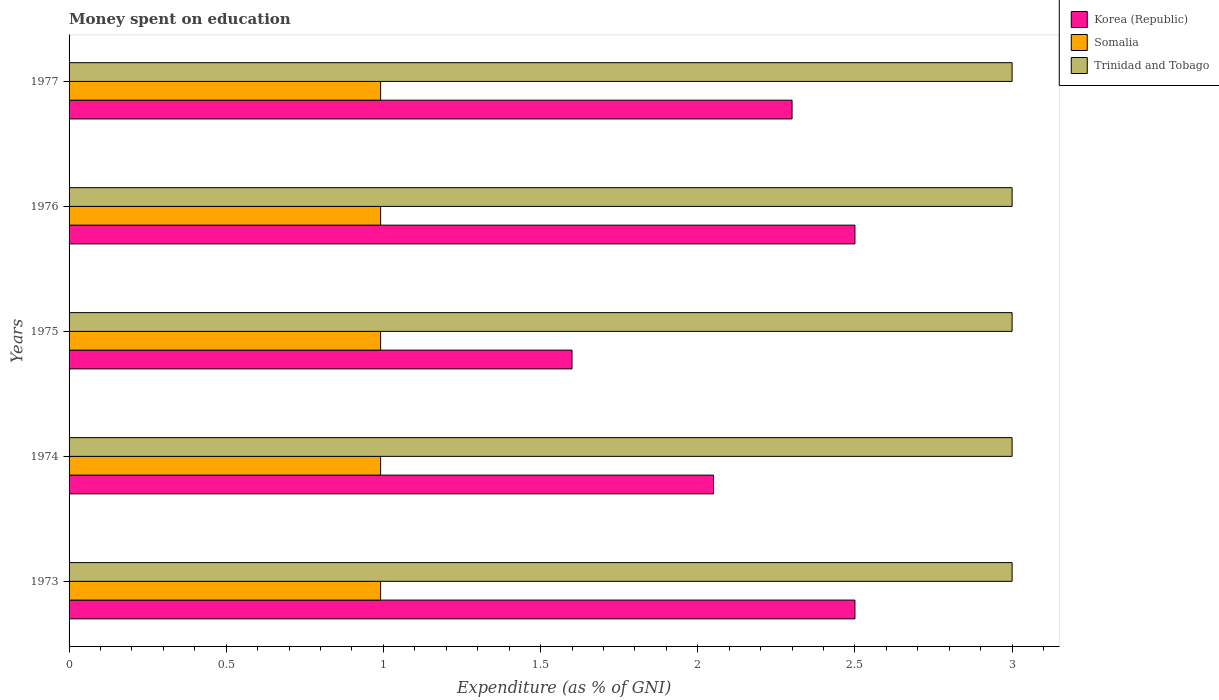How many different coloured bars are there?
Give a very brief answer. 3. Are the number of bars per tick equal to the number of legend labels?
Your answer should be very brief. Yes. Are the number of bars on each tick of the Y-axis equal?
Make the answer very short. Yes. How many bars are there on the 1st tick from the top?
Keep it short and to the point. 3. What is the label of the 1st group of bars from the top?
Your response must be concise. 1977. In how many cases, is the number of bars for a given year not equal to the number of legend labels?
Make the answer very short. 0. What is the amount of money spent on education in Somalia in 1977?
Your answer should be very brief. 0.99. Across all years, what is the minimum amount of money spent on education in Korea (Republic)?
Offer a very short reply. 1.6. In which year was the amount of money spent on education in Korea (Republic) minimum?
Your answer should be compact. 1975. What is the total amount of money spent on education in Korea (Republic) in the graph?
Make the answer very short. 10.95. What is the difference between the amount of money spent on education in Somalia in 1977 and the amount of money spent on education in Trinidad and Tobago in 1975?
Give a very brief answer. -2.01. In the year 1977, what is the difference between the amount of money spent on education in Somalia and amount of money spent on education in Trinidad and Tobago?
Give a very brief answer. -2.01. Is the amount of money spent on education in Korea (Republic) in 1974 less than that in 1976?
Your answer should be compact. Yes. What is the difference between the highest and the second highest amount of money spent on education in Korea (Republic)?
Your answer should be very brief. 0. What is the difference between the highest and the lowest amount of money spent on education in Somalia?
Make the answer very short. 0. In how many years, is the amount of money spent on education in Somalia greater than the average amount of money spent on education in Somalia taken over all years?
Ensure brevity in your answer.  5. What does the 3rd bar from the bottom in 1974 represents?
Offer a terse response. Trinidad and Tobago. How many bars are there?
Your response must be concise. 15. How many years are there in the graph?
Give a very brief answer. 5. What is the difference between two consecutive major ticks on the X-axis?
Your answer should be compact. 0.5. Are the values on the major ticks of X-axis written in scientific E-notation?
Your answer should be very brief. No. Does the graph contain any zero values?
Ensure brevity in your answer.  No. How many legend labels are there?
Offer a terse response. 3. What is the title of the graph?
Your response must be concise. Money spent on education. Does "Zambia" appear as one of the legend labels in the graph?
Offer a terse response. No. What is the label or title of the X-axis?
Ensure brevity in your answer.  Expenditure (as % of GNI). What is the Expenditure (as % of GNI) of Korea (Republic) in 1973?
Your response must be concise. 2.5. What is the Expenditure (as % of GNI) in Somalia in 1973?
Your response must be concise. 0.99. What is the Expenditure (as % of GNI) of Korea (Republic) in 1974?
Ensure brevity in your answer.  2.05. What is the Expenditure (as % of GNI) in Somalia in 1974?
Provide a succinct answer. 0.99. What is the Expenditure (as % of GNI) in Somalia in 1975?
Provide a short and direct response. 0.99. What is the Expenditure (as % of GNI) of Trinidad and Tobago in 1975?
Provide a short and direct response. 3. What is the Expenditure (as % of GNI) of Korea (Republic) in 1976?
Offer a very short reply. 2.5. What is the Expenditure (as % of GNI) in Somalia in 1976?
Give a very brief answer. 0.99. What is the Expenditure (as % of GNI) in Trinidad and Tobago in 1976?
Provide a succinct answer. 3. What is the Expenditure (as % of GNI) in Somalia in 1977?
Provide a succinct answer. 0.99. Across all years, what is the maximum Expenditure (as % of GNI) in Somalia?
Keep it short and to the point. 0.99. Across all years, what is the minimum Expenditure (as % of GNI) in Somalia?
Provide a short and direct response. 0.99. What is the total Expenditure (as % of GNI) of Korea (Republic) in the graph?
Offer a very short reply. 10.95. What is the total Expenditure (as % of GNI) in Somalia in the graph?
Offer a terse response. 4.96. What is the difference between the Expenditure (as % of GNI) of Korea (Republic) in 1973 and that in 1974?
Your answer should be compact. 0.45. What is the difference between the Expenditure (as % of GNI) of Trinidad and Tobago in 1973 and that in 1974?
Offer a very short reply. 0. What is the difference between the Expenditure (as % of GNI) in Korea (Republic) in 1973 and that in 1977?
Give a very brief answer. 0.2. What is the difference between the Expenditure (as % of GNI) in Korea (Republic) in 1974 and that in 1975?
Offer a terse response. 0.45. What is the difference between the Expenditure (as % of GNI) in Somalia in 1974 and that in 1975?
Provide a short and direct response. 0. What is the difference between the Expenditure (as % of GNI) in Korea (Republic) in 1974 and that in 1976?
Your response must be concise. -0.45. What is the difference between the Expenditure (as % of GNI) of Trinidad and Tobago in 1974 and that in 1976?
Give a very brief answer. 0. What is the difference between the Expenditure (as % of GNI) of Korea (Republic) in 1974 and that in 1977?
Your response must be concise. -0.25. What is the difference between the Expenditure (as % of GNI) of Somalia in 1974 and that in 1977?
Offer a very short reply. 0. What is the difference between the Expenditure (as % of GNI) of Somalia in 1975 and that in 1976?
Provide a short and direct response. 0. What is the difference between the Expenditure (as % of GNI) of Trinidad and Tobago in 1975 and that in 1976?
Keep it short and to the point. 0. What is the difference between the Expenditure (as % of GNI) in Korea (Republic) in 1975 and that in 1977?
Make the answer very short. -0.7. What is the difference between the Expenditure (as % of GNI) in Somalia in 1975 and that in 1977?
Offer a terse response. 0. What is the difference between the Expenditure (as % of GNI) of Somalia in 1976 and that in 1977?
Ensure brevity in your answer.  0. What is the difference between the Expenditure (as % of GNI) in Korea (Republic) in 1973 and the Expenditure (as % of GNI) in Somalia in 1974?
Make the answer very short. 1.51. What is the difference between the Expenditure (as % of GNI) in Korea (Republic) in 1973 and the Expenditure (as % of GNI) in Trinidad and Tobago in 1974?
Provide a succinct answer. -0.5. What is the difference between the Expenditure (as % of GNI) of Somalia in 1973 and the Expenditure (as % of GNI) of Trinidad and Tobago in 1974?
Your answer should be compact. -2.01. What is the difference between the Expenditure (as % of GNI) of Korea (Republic) in 1973 and the Expenditure (as % of GNI) of Somalia in 1975?
Make the answer very short. 1.51. What is the difference between the Expenditure (as % of GNI) of Korea (Republic) in 1973 and the Expenditure (as % of GNI) of Trinidad and Tobago in 1975?
Ensure brevity in your answer.  -0.5. What is the difference between the Expenditure (as % of GNI) of Somalia in 1973 and the Expenditure (as % of GNI) of Trinidad and Tobago in 1975?
Provide a short and direct response. -2.01. What is the difference between the Expenditure (as % of GNI) of Korea (Republic) in 1973 and the Expenditure (as % of GNI) of Somalia in 1976?
Provide a succinct answer. 1.51. What is the difference between the Expenditure (as % of GNI) in Korea (Republic) in 1973 and the Expenditure (as % of GNI) in Trinidad and Tobago in 1976?
Provide a short and direct response. -0.5. What is the difference between the Expenditure (as % of GNI) in Somalia in 1973 and the Expenditure (as % of GNI) in Trinidad and Tobago in 1976?
Your answer should be very brief. -2.01. What is the difference between the Expenditure (as % of GNI) in Korea (Republic) in 1973 and the Expenditure (as % of GNI) in Somalia in 1977?
Keep it short and to the point. 1.51. What is the difference between the Expenditure (as % of GNI) of Korea (Republic) in 1973 and the Expenditure (as % of GNI) of Trinidad and Tobago in 1977?
Your answer should be very brief. -0.5. What is the difference between the Expenditure (as % of GNI) of Somalia in 1973 and the Expenditure (as % of GNI) of Trinidad and Tobago in 1977?
Your response must be concise. -2.01. What is the difference between the Expenditure (as % of GNI) of Korea (Republic) in 1974 and the Expenditure (as % of GNI) of Somalia in 1975?
Your answer should be very brief. 1.06. What is the difference between the Expenditure (as % of GNI) in Korea (Republic) in 1974 and the Expenditure (as % of GNI) in Trinidad and Tobago in 1975?
Ensure brevity in your answer.  -0.95. What is the difference between the Expenditure (as % of GNI) in Somalia in 1974 and the Expenditure (as % of GNI) in Trinidad and Tobago in 1975?
Keep it short and to the point. -2.01. What is the difference between the Expenditure (as % of GNI) in Korea (Republic) in 1974 and the Expenditure (as % of GNI) in Somalia in 1976?
Make the answer very short. 1.06. What is the difference between the Expenditure (as % of GNI) of Korea (Republic) in 1974 and the Expenditure (as % of GNI) of Trinidad and Tobago in 1976?
Provide a short and direct response. -0.95. What is the difference between the Expenditure (as % of GNI) in Somalia in 1974 and the Expenditure (as % of GNI) in Trinidad and Tobago in 1976?
Make the answer very short. -2.01. What is the difference between the Expenditure (as % of GNI) of Korea (Republic) in 1974 and the Expenditure (as % of GNI) of Somalia in 1977?
Provide a short and direct response. 1.06. What is the difference between the Expenditure (as % of GNI) in Korea (Republic) in 1974 and the Expenditure (as % of GNI) in Trinidad and Tobago in 1977?
Provide a short and direct response. -0.95. What is the difference between the Expenditure (as % of GNI) of Somalia in 1974 and the Expenditure (as % of GNI) of Trinidad and Tobago in 1977?
Keep it short and to the point. -2.01. What is the difference between the Expenditure (as % of GNI) of Korea (Republic) in 1975 and the Expenditure (as % of GNI) of Somalia in 1976?
Your answer should be very brief. 0.61. What is the difference between the Expenditure (as % of GNI) in Korea (Republic) in 1975 and the Expenditure (as % of GNI) in Trinidad and Tobago in 1976?
Your response must be concise. -1.4. What is the difference between the Expenditure (as % of GNI) of Somalia in 1975 and the Expenditure (as % of GNI) of Trinidad and Tobago in 1976?
Offer a very short reply. -2.01. What is the difference between the Expenditure (as % of GNI) in Korea (Republic) in 1975 and the Expenditure (as % of GNI) in Somalia in 1977?
Offer a very short reply. 0.61. What is the difference between the Expenditure (as % of GNI) of Korea (Republic) in 1975 and the Expenditure (as % of GNI) of Trinidad and Tobago in 1977?
Make the answer very short. -1.4. What is the difference between the Expenditure (as % of GNI) in Somalia in 1975 and the Expenditure (as % of GNI) in Trinidad and Tobago in 1977?
Offer a very short reply. -2.01. What is the difference between the Expenditure (as % of GNI) of Korea (Republic) in 1976 and the Expenditure (as % of GNI) of Somalia in 1977?
Your answer should be compact. 1.51. What is the difference between the Expenditure (as % of GNI) in Korea (Republic) in 1976 and the Expenditure (as % of GNI) in Trinidad and Tobago in 1977?
Offer a terse response. -0.5. What is the difference between the Expenditure (as % of GNI) of Somalia in 1976 and the Expenditure (as % of GNI) of Trinidad and Tobago in 1977?
Your answer should be compact. -2.01. What is the average Expenditure (as % of GNI) of Korea (Republic) per year?
Keep it short and to the point. 2.19. What is the average Expenditure (as % of GNI) in Somalia per year?
Make the answer very short. 0.99. What is the average Expenditure (as % of GNI) in Trinidad and Tobago per year?
Your answer should be compact. 3. In the year 1973, what is the difference between the Expenditure (as % of GNI) of Korea (Republic) and Expenditure (as % of GNI) of Somalia?
Make the answer very short. 1.51. In the year 1973, what is the difference between the Expenditure (as % of GNI) in Somalia and Expenditure (as % of GNI) in Trinidad and Tobago?
Your answer should be very brief. -2.01. In the year 1974, what is the difference between the Expenditure (as % of GNI) in Korea (Republic) and Expenditure (as % of GNI) in Somalia?
Your answer should be very brief. 1.06. In the year 1974, what is the difference between the Expenditure (as % of GNI) of Korea (Republic) and Expenditure (as % of GNI) of Trinidad and Tobago?
Your answer should be compact. -0.95. In the year 1974, what is the difference between the Expenditure (as % of GNI) of Somalia and Expenditure (as % of GNI) of Trinidad and Tobago?
Make the answer very short. -2.01. In the year 1975, what is the difference between the Expenditure (as % of GNI) in Korea (Republic) and Expenditure (as % of GNI) in Somalia?
Make the answer very short. 0.61. In the year 1975, what is the difference between the Expenditure (as % of GNI) of Somalia and Expenditure (as % of GNI) of Trinidad and Tobago?
Offer a terse response. -2.01. In the year 1976, what is the difference between the Expenditure (as % of GNI) in Korea (Republic) and Expenditure (as % of GNI) in Somalia?
Make the answer very short. 1.51. In the year 1976, what is the difference between the Expenditure (as % of GNI) in Somalia and Expenditure (as % of GNI) in Trinidad and Tobago?
Give a very brief answer. -2.01. In the year 1977, what is the difference between the Expenditure (as % of GNI) of Korea (Republic) and Expenditure (as % of GNI) of Somalia?
Your answer should be very brief. 1.31. In the year 1977, what is the difference between the Expenditure (as % of GNI) of Somalia and Expenditure (as % of GNI) of Trinidad and Tobago?
Your answer should be compact. -2.01. What is the ratio of the Expenditure (as % of GNI) of Korea (Republic) in 1973 to that in 1974?
Your response must be concise. 1.22. What is the ratio of the Expenditure (as % of GNI) in Korea (Republic) in 1973 to that in 1975?
Offer a terse response. 1.56. What is the ratio of the Expenditure (as % of GNI) in Somalia in 1973 to that in 1975?
Your answer should be compact. 1. What is the ratio of the Expenditure (as % of GNI) in Trinidad and Tobago in 1973 to that in 1975?
Give a very brief answer. 1. What is the ratio of the Expenditure (as % of GNI) of Korea (Republic) in 1973 to that in 1976?
Your response must be concise. 1. What is the ratio of the Expenditure (as % of GNI) of Korea (Republic) in 1973 to that in 1977?
Give a very brief answer. 1.09. What is the ratio of the Expenditure (as % of GNI) in Somalia in 1973 to that in 1977?
Provide a succinct answer. 1. What is the ratio of the Expenditure (as % of GNI) of Korea (Republic) in 1974 to that in 1975?
Give a very brief answer. 1.28. What is the ratio of the Expenditure (as % of GNI) of Somalia in 1974 to that in 1975?
Ensure brevity in your answer.  1. What is the ratio of the Expenditure (as % of GNI) in Trinidad and Tobago in 1974 to that in 1975?
Offer a very short reply. 1. What is the ratio of the Expenditure (as % of GNI) in Korea (Republic) in 1974 to that in 1976?
Offer a terse response. 0.82. What is the ratio of the Expenditure (as % of GNI) of Somalia in 1974 to that in 1976?
Keep it short and to the point. 1. What is the ratio of the Expenditure (as % of GNI) of Korea (Republic) in 1974 to that in 1977?
Offer a very short reply. 0.89. What is the ratio of the Expenditure (as % of GNI) of Trinidad and Tobago in 1974 to that in 1977?
Ensure brevity in your answer.  1. What is the ratio of the Expenditure (as % of GNI) of Korea (Republic) in 1975 to that in 1976?
Provide a succinct answer. 0.64. What is the ratio of the Expenditure (as % of GNI) in Somalia in 1975 to that in 1976?
Your answer should be compact. 1. What is the ratio of the Expenditure (as % of GNI) of Korea (Republic) in 1975 to that in 1977?
Your answer should be very brief. 0.7. What is the ratio of the Expenditure (as % of GNI) in Somalia in 1975 to that in 1977?
Keep it short and to the point. 1. What is the ratio of the Expenditure (as % of GNI) in Korea (Republic) in 1976 to that in 1977?
Your answer should be very brief. 1.09. What is the ratio of the Expenditure (as % of GNI) in Trinidad and Tobago in 1976 to that in 1977?
Offer a very short reply. 1. What is the difference between the highest and the second highest Expenditure (as % of GNI) in Somalia?
Your answer should be compact. 0. What is the difference between the highest and the lowest Expenditure (as % of GNI) in Trinidad and Tobago?
Offer a terse response. 0. 